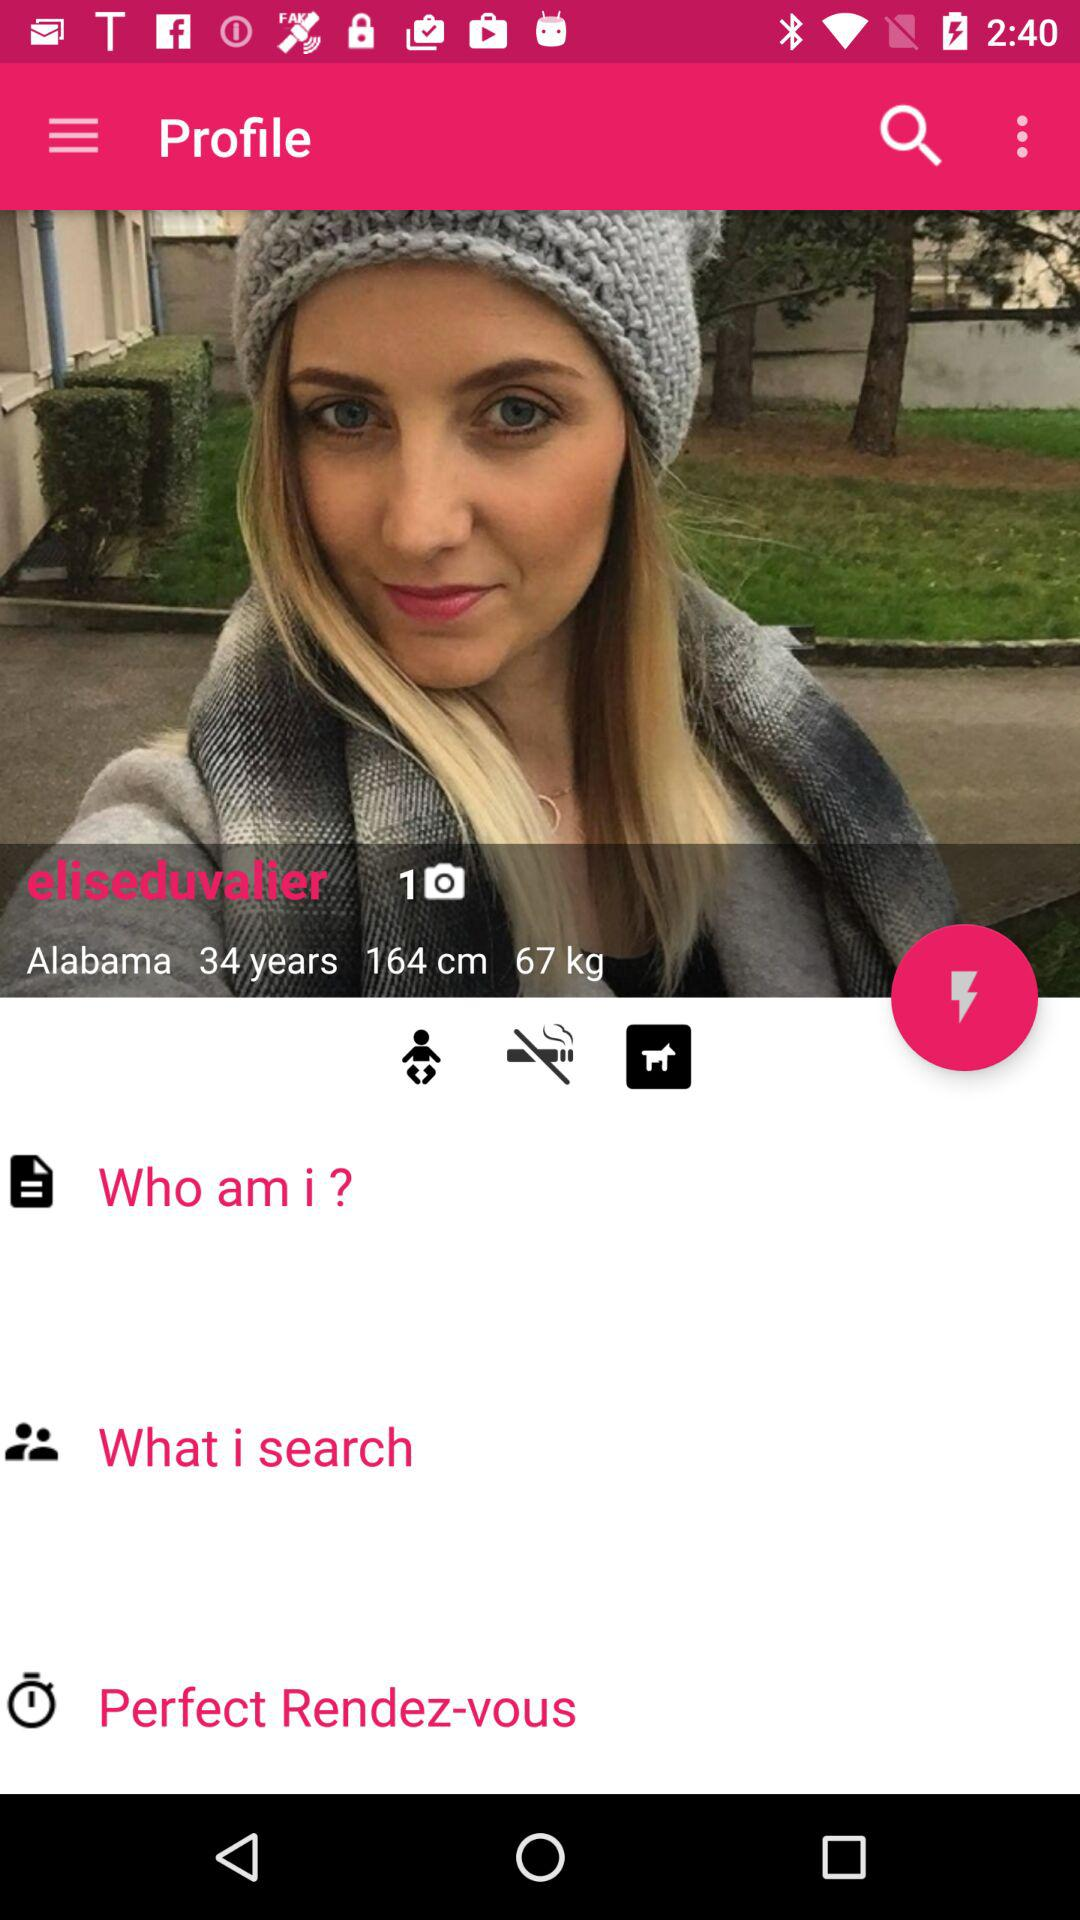What's the age of the girl? The age of the girl is 34 years old. 